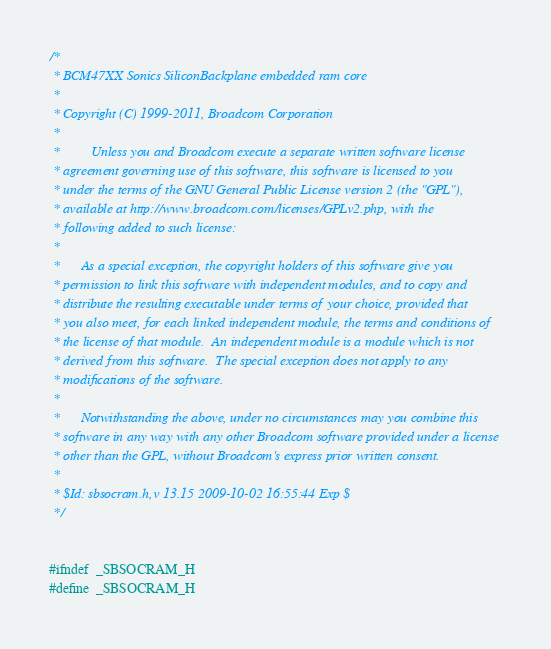<code> <loc_0><loc_0><loc_500><loc_500><_C_>/*
 * BCM47XX Sonics SiliconBackplane embedded ram core
 *
 * Copyright (C) 1999-2011, Broadcom Corporation
 * 
 *         Unless you and Broadcom execute a separate written software license
 * agreement governing use of this software, this software is licensed to you
 * under the terms of the GNU General Public License version 2 (the "GPL"),
 * available at http://www.broadcom.com/licenses/GPLv2.php, with the
 * following added to such license:
 * 
 *      As a special exception, the copyright holders of this software give you
 * permission to link this software with independent modules, and to copy and
 * distribute the resulting executable under terms of your choice, provided that
 * you also meet, for each linked independent module, the terms and conditions of
 * the license of that module.  An independent module is a module which is not
 * derived from this software.  The special exception does not apply to any
 * modifications of the software.
 * 
 *      Notwithstanding the above, under no circumstances may you combine this
 * software in any way with any other Broadcom software provided under a license
 * other than the GPL, without Broadcom's express prior written consent.
 *
 * $Id: sbsocram.h,v 13.15 2009-10-02 16:55:44 Exp $
 */


#ifndef	_SBSOCRAM_H
#define	_SBSOCRAM_H
</code> 